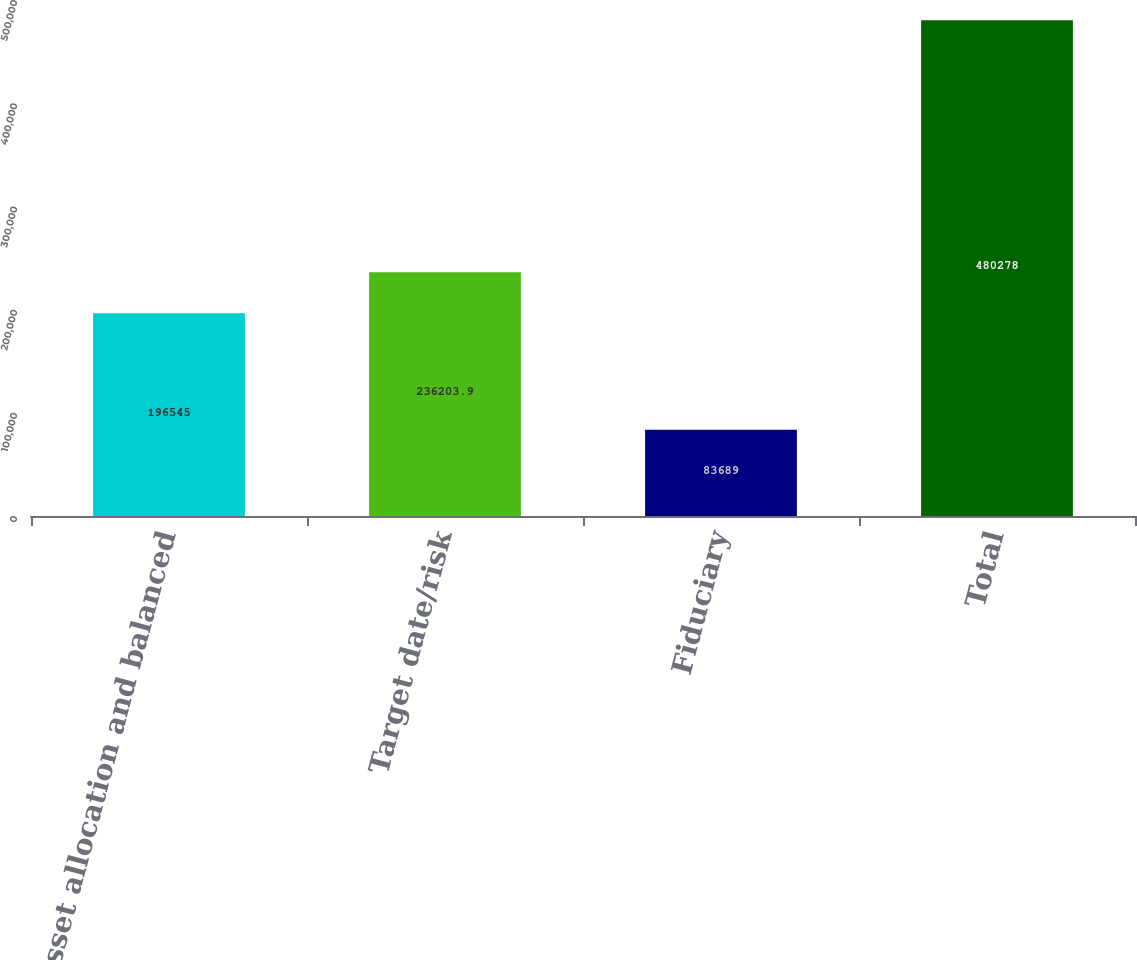Convert chart. <chart><loc_0><loc_0><loc_500><loc_500><bar_chart><fcel>Asset allocation and balanced<fcel>Target date/risk<fcel>Fiduciary<fcel>Total<nl><fcel>196545<fcel>236204<fcel>83689<fcel>480278<nl></chart> 